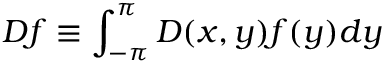<formula> <loc_0><loc_0><loc_500><loc_500>D f \equiv \int _ { - \pi } ^ { \pi } D ( x , y ) f ( y ) d y</formula> 